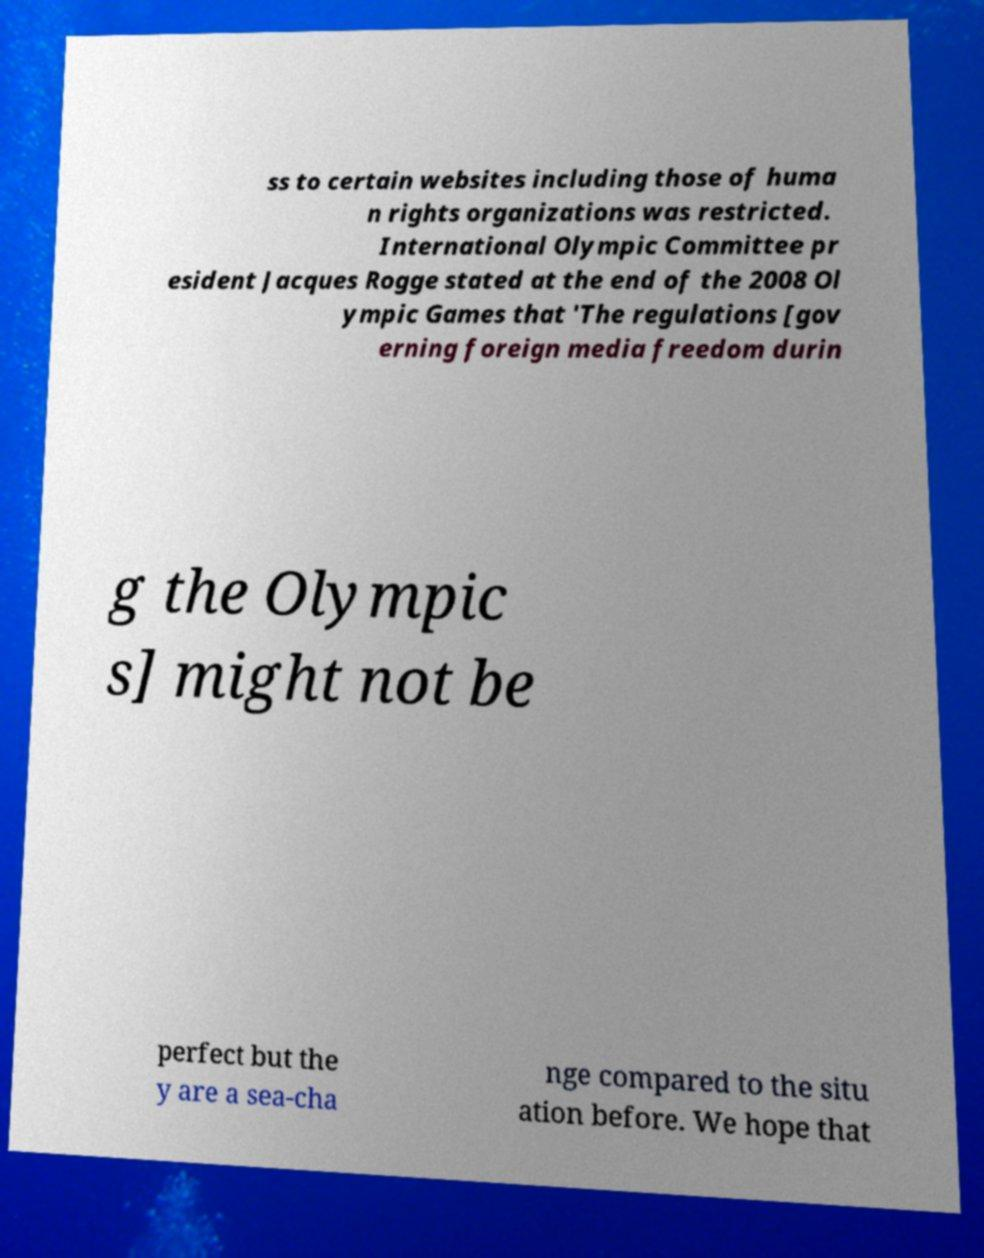There's text embedded in this image that I need extracted. Can you transcribe it verbatim? ss to certain websites including those of huma n rights organizations was restricted. International Olympic Committee pr esident Jacques Rogge stated at the end of the 2008 Ol ympic Games that 'The regulations [gov erning foreign media freedom durin g the Olympic s] might not be perfect but the y are a sea-cha nge compared to the situ ation before. We hope that 